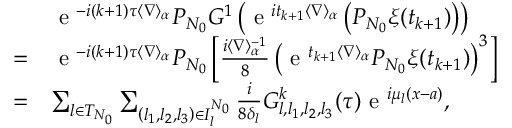<formula> <loc_0><loc_0><loc_500><loc_500>\begin{array} { r l } & { e ^ { - i ( k + 1 ) \tau \langle \nabla \rangle _ { \alpha } } P _ { N _ { 0 } } G ^ { 1 } \left ( e ^ { i t _ { k + 1 } \langle \nabla \rangle _ { \alpha } } \left ( P _ { N _ { 0 } } \xi ( t _ { k + 1 } ) \right ) \right ) } \\ { = } & { e ^ { - i ( k + 1 ) \tau \langle \nabla \rangle _ { \alpha } } P _ { N _ { 0 } } \left [ \frac { i \langle \nabla \rangle _ { \alpha } ^ { - 1 } } { 8 } \left ( e ^ { t _ { k + 1 } \langle \nabla \rangle _ { \alpha } } P _ { N _ { 0 } } \xi ( t _ { k + 1 } ) \right ) ^ { 3 } \right ] } \\ { = } & { \sum _ { l \in { T } _ { N _ { 0 } } } \sum _ { \left ( l _ { 1 } , l _ { 2 } , l _ { 3 } \right ) \in { I } _ { l } ^ { N _ { 0 } } } \frac { i } { 8 \delta _ { l } } { G } _ { l , l _ { 1 } , l _ { 2 } , l _ { 3 } } ^ { k } ( \tau ) e ^ { i \mu _ { l } ( x - a ) } , } \end{array}</formula> 